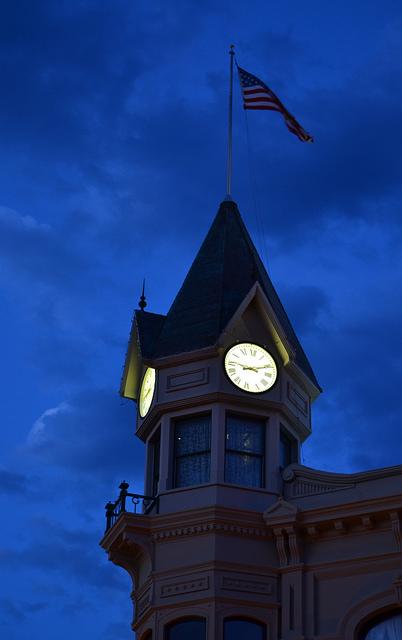What is on top of the tower?
Quick response, please. Flag. Is the clock on the tower lit up?
Keep it brief. Yes. How many clocks are there?
Quick response, please. 2. 